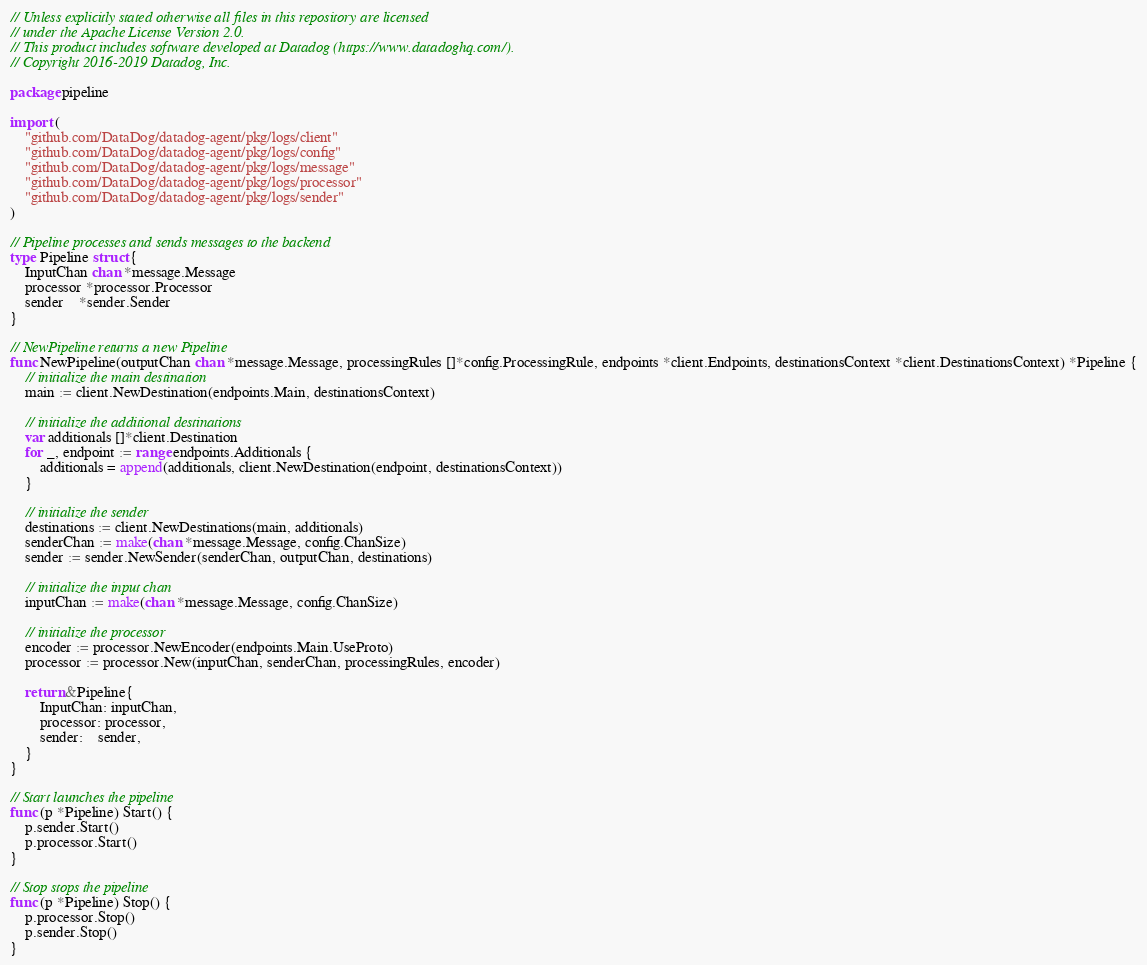Convert code to text. <code><loc_0><loc_0><loc_500><loc_500><_Go_>// Unless explicitly stated otherwise all files in this repository are licensed
// under the Apache License Version 2.0.
// This product includes software developed at Datadog (https://www.datadoghq.com/).
// Copyright 2016-2019 Datadog, Inc.

package pipeline

import (
	"github.com/DataDog/datadog-agent/pkg/logs/client"
	"github.com/DataDog/datadog-agent/pkg/logs/config"
	"github.com/DataDog/datadog-agent/pkg/logs/message"
	"github.com/DataDog/datadog-agent/pkg/logs/processor"
	"github.com/DataDog/datadog-agent/pkg/logs/sender"
)

// Pipeline processes and sends messages to the backend
type Pipeline struct {
	InputChan chan *message.Message
	processor *processor.Processor
	sender    *sender.Sender
}

// NewPipeline returns a new Pipeline
func NewPipeline(outputChan chan *message.Message, processingRules []*config.ProcessingRule, endpoints *client.Endpoints, destinationsContext *client.DestinationsContext) *Pipeline {
	// initialize the main destination
	main := client.NewDestination(endpoints.Main, destinationsContext)

	// initialize the additional destinations
	var additionals []*client.Destination
	for _, endpoint := range endpoints.Additionals {
		additionals = append(additionals, client.NewDestination(endpoint, destinationsContext))
	}

	// initialize the sender
	destinations := client.NewDestinations(main, additionals)
	senderChan := make(chan *message.Message, config.ChanSize)
	sender := sender.NewSender(senderChan, outputChan, destinations)

	// initialize the input chan
	inputChan := make(chan *message.Message, config.ChanSize)

	// initialize the processor
	encoder := processor.NewEncoder(endpoints.Main.UseProto)
	processor := processor.New(inputChan, senderChan, processingRules, encoder)

	return &Pipeline{
		InputChan: inputChan,
		processor: processor,
		sender:    sender,
	}
}

// Start launches the pipeline
func (p *Pipeline) Start() {
	p.sender.Start()
	p.processor.Start()
}

// Stop stops the pipeline
func (p *Pipeline) Stop() {
	p.processor.Stop()
	p.sender.Stop()
}
</code> 